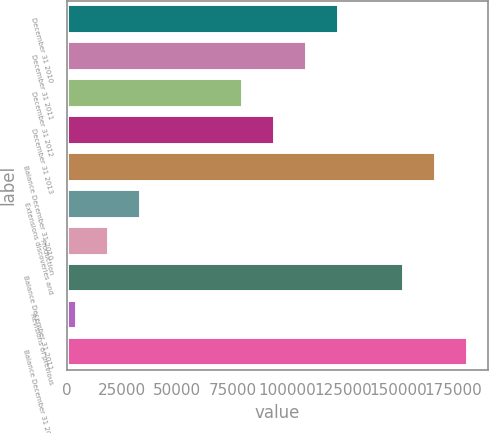<chart> <loc_0><loc_0><loc_500><loc_500><bar_chart><fcel>December 31 2010<fcel>December 31 2011<fcel>December 31 2012<fcel>December 31 2013<fcel>Balance December 31 2010<fcel>Extensions discoveries and<fcel>Production<fcel>Balance December 31 2011<fcel>Revisions of previous<fcel>Balance December 31 2012<nl><fcel>123425<fcel>108849<fcel>79695<fcel>94271.8<fcel>167156<fcel>33730.6<fcel>19153.8<fcel>152579<fcel>4577<fcel>181733<nl></chart> 